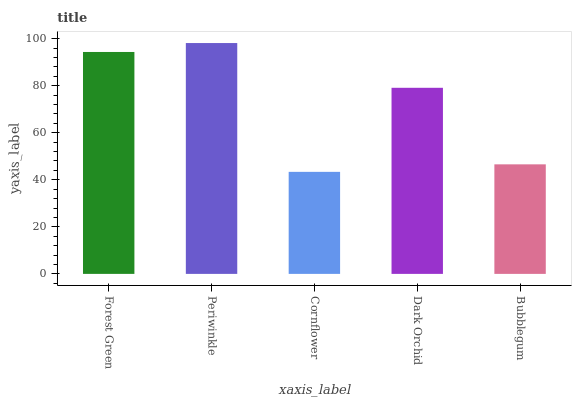Is Cornflower the minimum?
Answer yes or no. Yes. Is Periwinkle the maximum?
Answer yes or no. Yes. Is Periwinkle the minimum?
Answer yes or no. No. Is Cornflower the maximum?
Answer yes or no. No. Is Periwinkle greater than Cornflower?
Answer yes or no. Yes. Is Cornflower less than Periwinkle?
Answer yes or no. Yes. Is Cornflower greater than Periwinkle?
Answer yes or no. No. Is Periwinkle less than Cornflower?
Answer yes or no. No. Is Dark Orchid the high median?
Answer yes or no. Yes. Is Dark Orchid the low median?
Answer yes or no. Yes. Is Periwinkle the high median?
Answer yes or no. No. Is Periwinkle the low median?
Answer yes or no. No. 